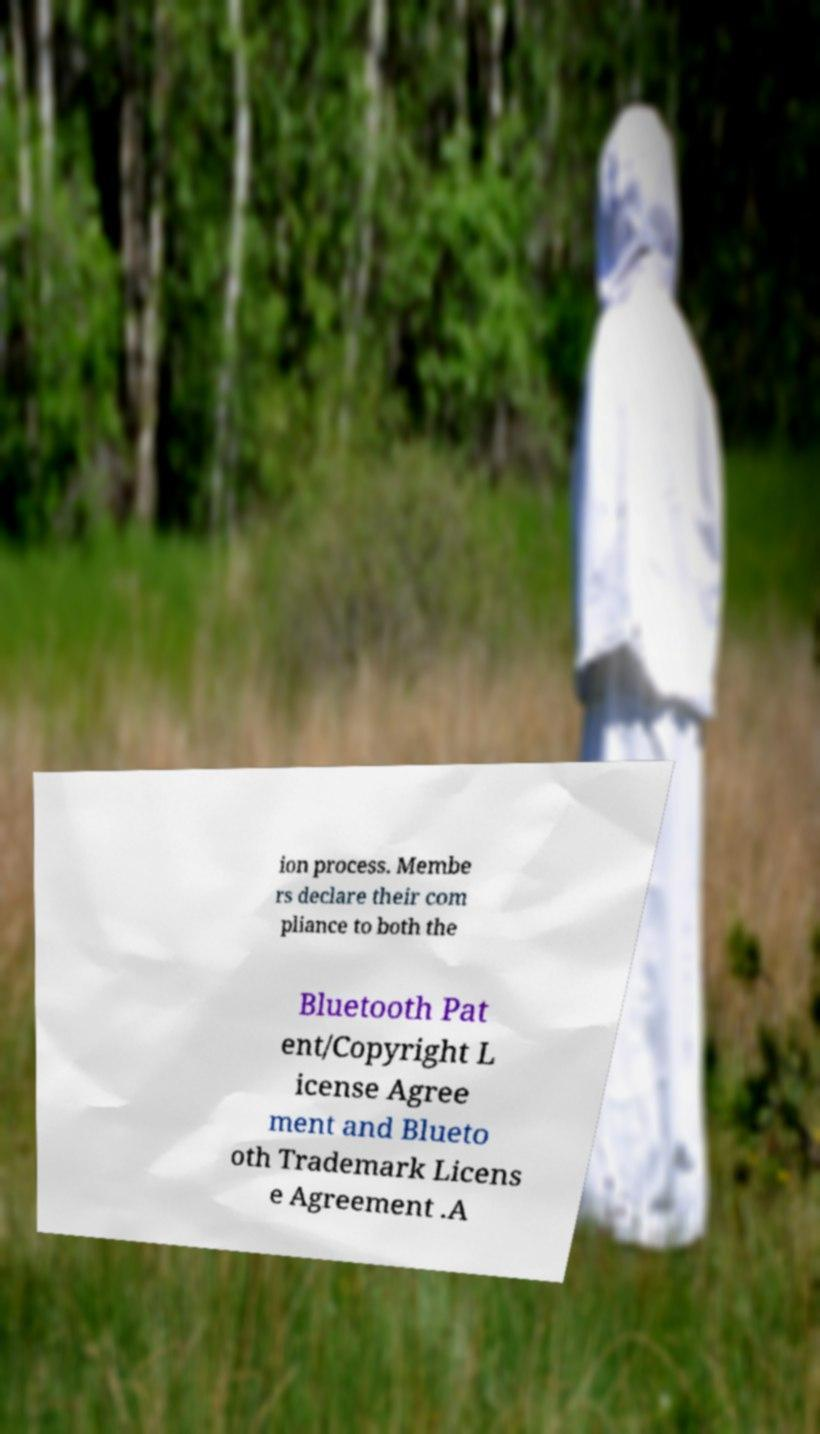I need the written content from this picture converted into text. Can you do that? ion process. Membe rs declare their com pliance to both the Bluetooth Pat ent/Copyright L icense Agree ment and Blueto oth Trademark Licens e Agreement .A 